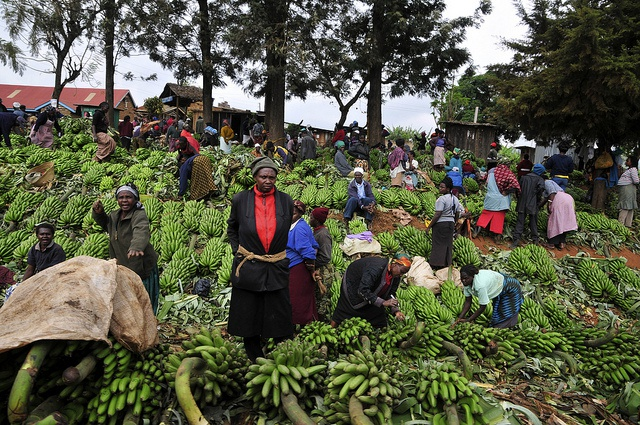Describe the objects in this image and their specific colors. I can see banana in lightgray, black, darkgreen, and olive tones, people in lightgray, black, gray, darkgreen, and maroon tones, people in lightgray, black, red, and gray tones, people in lightgray, black, gray, maroon, and darkgreen tones, and banana in lightgray, black, darkgreen, and olive tones in this image. 